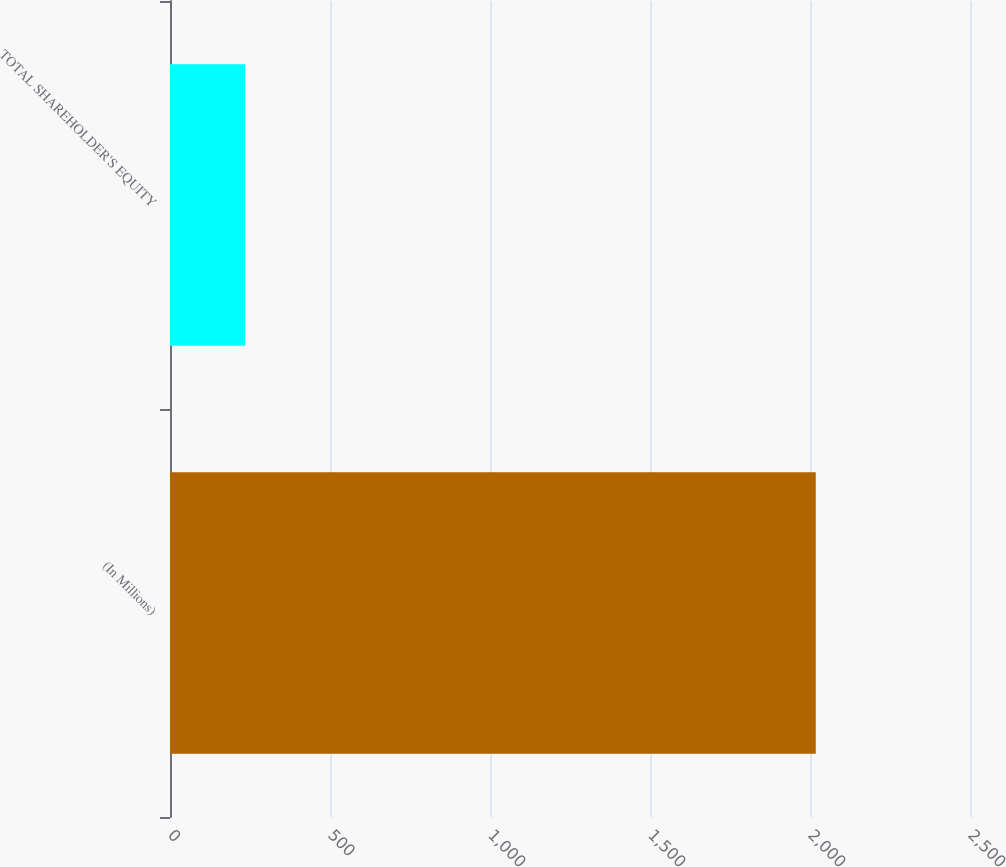<chart> <loc_0><loc_0><loc_500><loc_500><bar_chart><fcel>(In Millions)<fcel>TOTAL SHAREHOLDER'S EQUITY<nl><fcel>2018<fcel>235<nl></chart> 